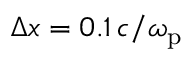<formula> <loc_0><loc_0><loc_500><loc_500>\Delta x = 0 . 1 \, c / \omega _ { p }</formula> 